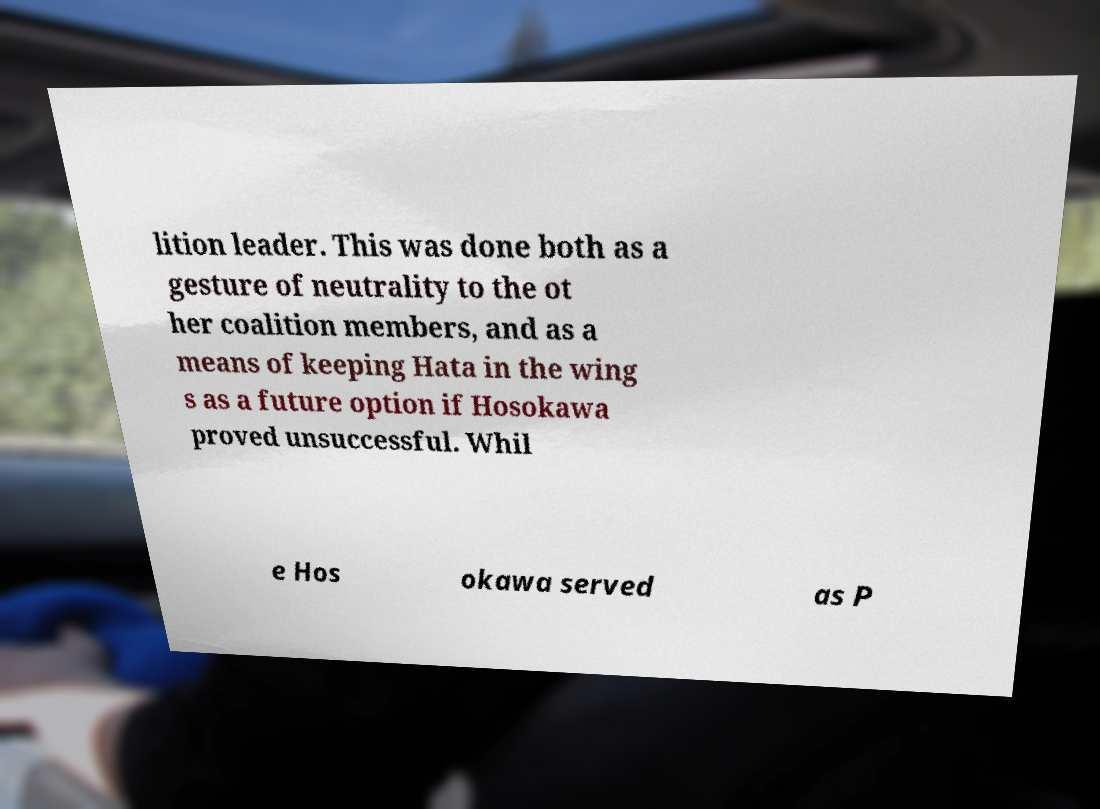Could you assist in decoding the text presented in this image and type it out clearly? lition leader. This was done both as a gesture of neutrality to the ot her coalition members, and as a means of keeping Hata in the wing s as a future option if Hosokawa proved unsuccessful. Whil e Hos okawa served as P 